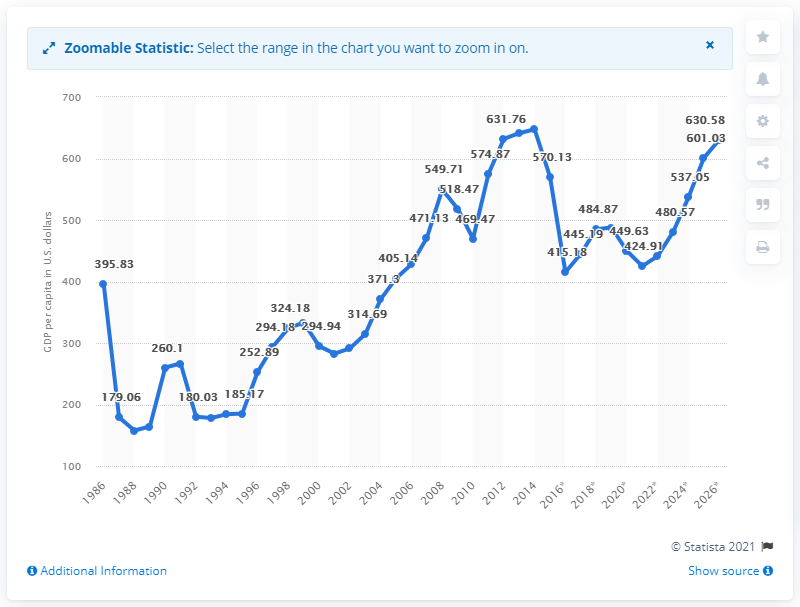Indicate a few pertinent items in this graphic. The GDP per capita in Mozambique in 2019 was 487.69. 